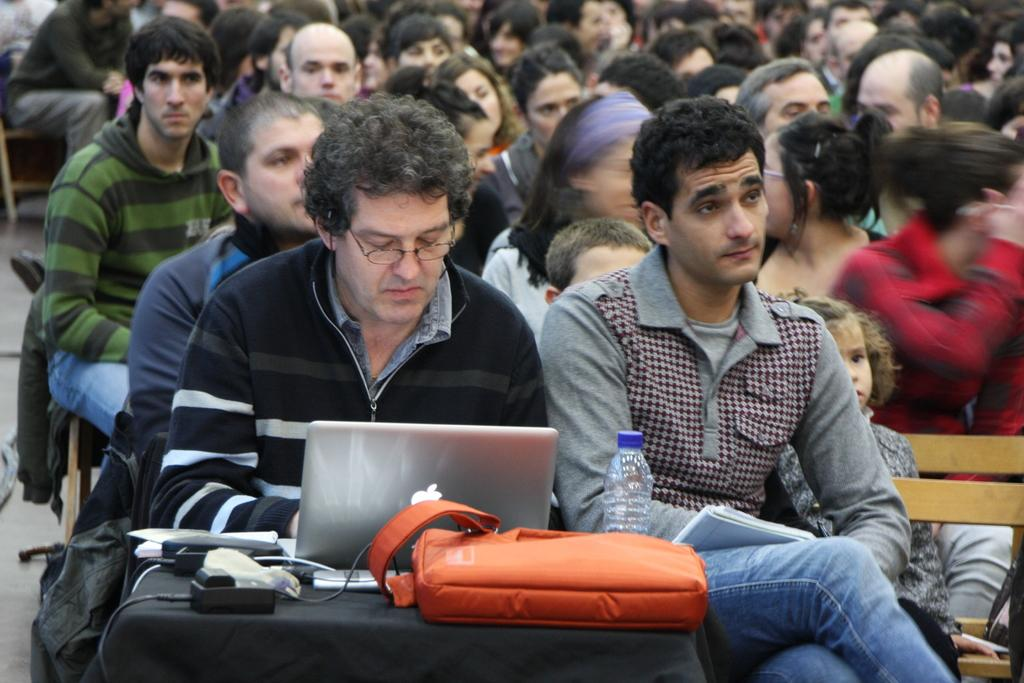How many people are sitting on the bench in the image? There are two persons sitting on a bench in the image. What electronic device is on the table in the image? There is a laptop on a table in the image. What else is on the table in the image? There is a bag, a bottle, and a charger on the table in the image. Can you describe the people in the background of the image? There is a group of persons in the background of the image. What type of authority is depicted in the image? There is no authority figure present in the image. Can you see a stamp on the table in the image? There is no stamp present on the table in the image. 